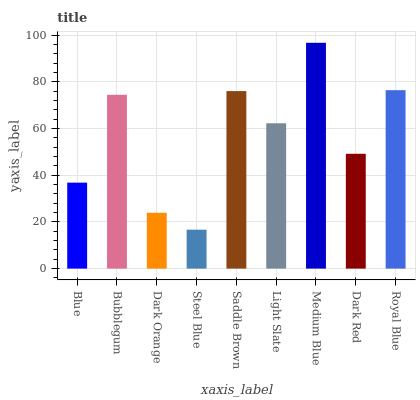Is Steel Blue the minimum?
Answer yes or no. Yes. Is Medium Blue the maximum?
Answer yes or no. Yes. Is Bubblegum the minimum?
Answer yes or no. No. Is Bubblegum the maximum?
Answer yes or no. No. Is Bubblegum greater than Blue?
Answer yes or no. Yes. Is Blue less than Bubblegum?
Answer yes or no. Yes. Is Blue greater than Bubblegum?
Answer yes or no. No. Is Bubblegum less than Blue?
Answer yes or no. No. Is Light Slate the high median?
Answer yes or no. Yes. Is Light Slate the low median?
Answer yes or no. Yes. Is Blue the high median?
Answer yes or no. No. Is Dark Red the low median?
Answer yes or no. No. 